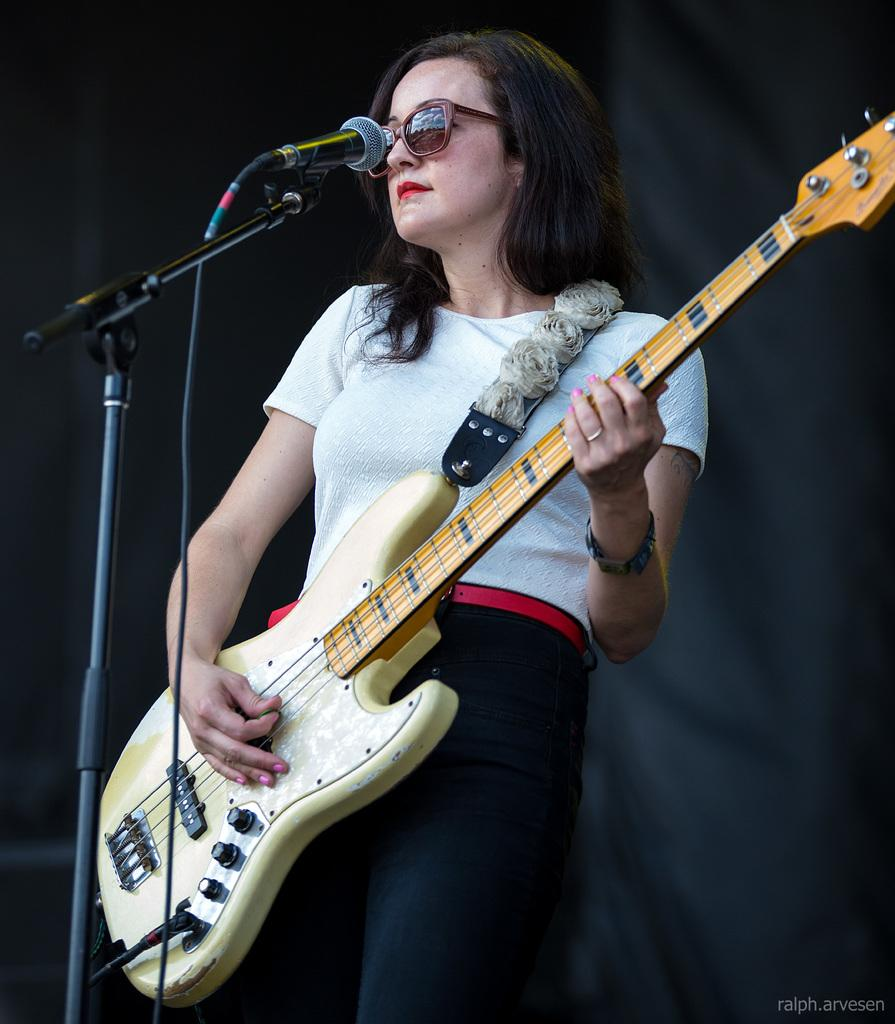What is the woman in the image doing? The woman is playing a guitar. What object is in front of the woman? There is a microphone in front of the woman. What color is the background of the image? The background of the image is black. Can you see any branches in the image? There are no branches visible in the image. What type of cup is the woman holding while playing the guitar? The woman is not holding a cup in the image; she is playing the guitar and there is a microphone in front of her. 